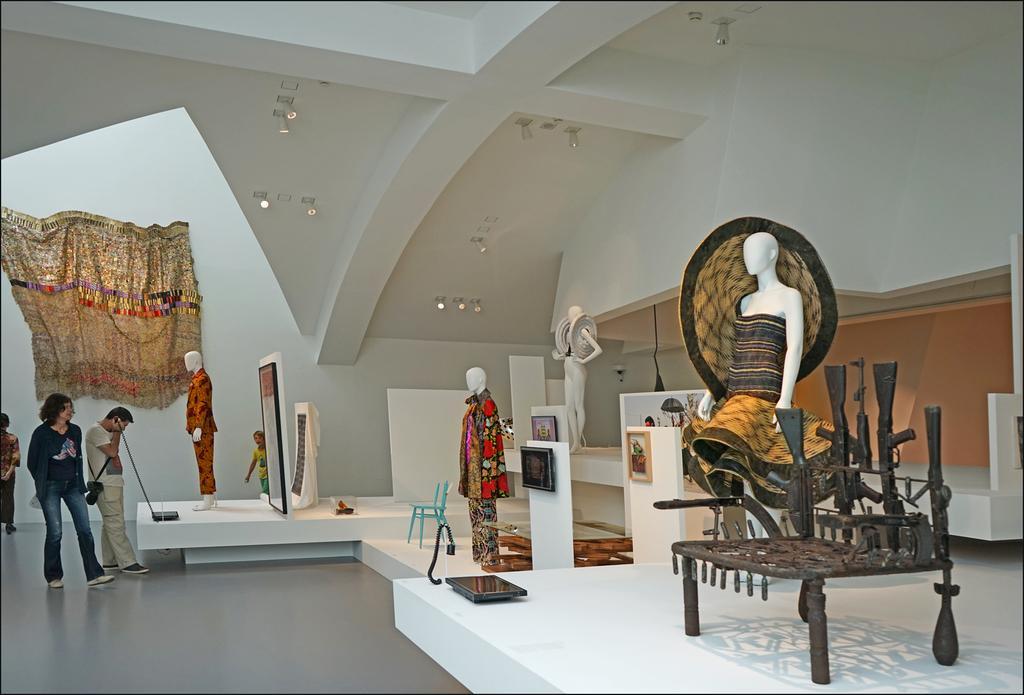Can you describe this image briefly? In this picture there are some people standing here and some statues with different types of clothes 